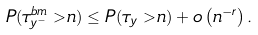<formula> <loc_0><loc_0><loc_500><loc_500>P ( \tau ^ { b m } _ { y ^ { - } } > n ) \leq P ( \tau _ { y } > n ) + o \left ( n ^ { - r } \right ) .</formula> 